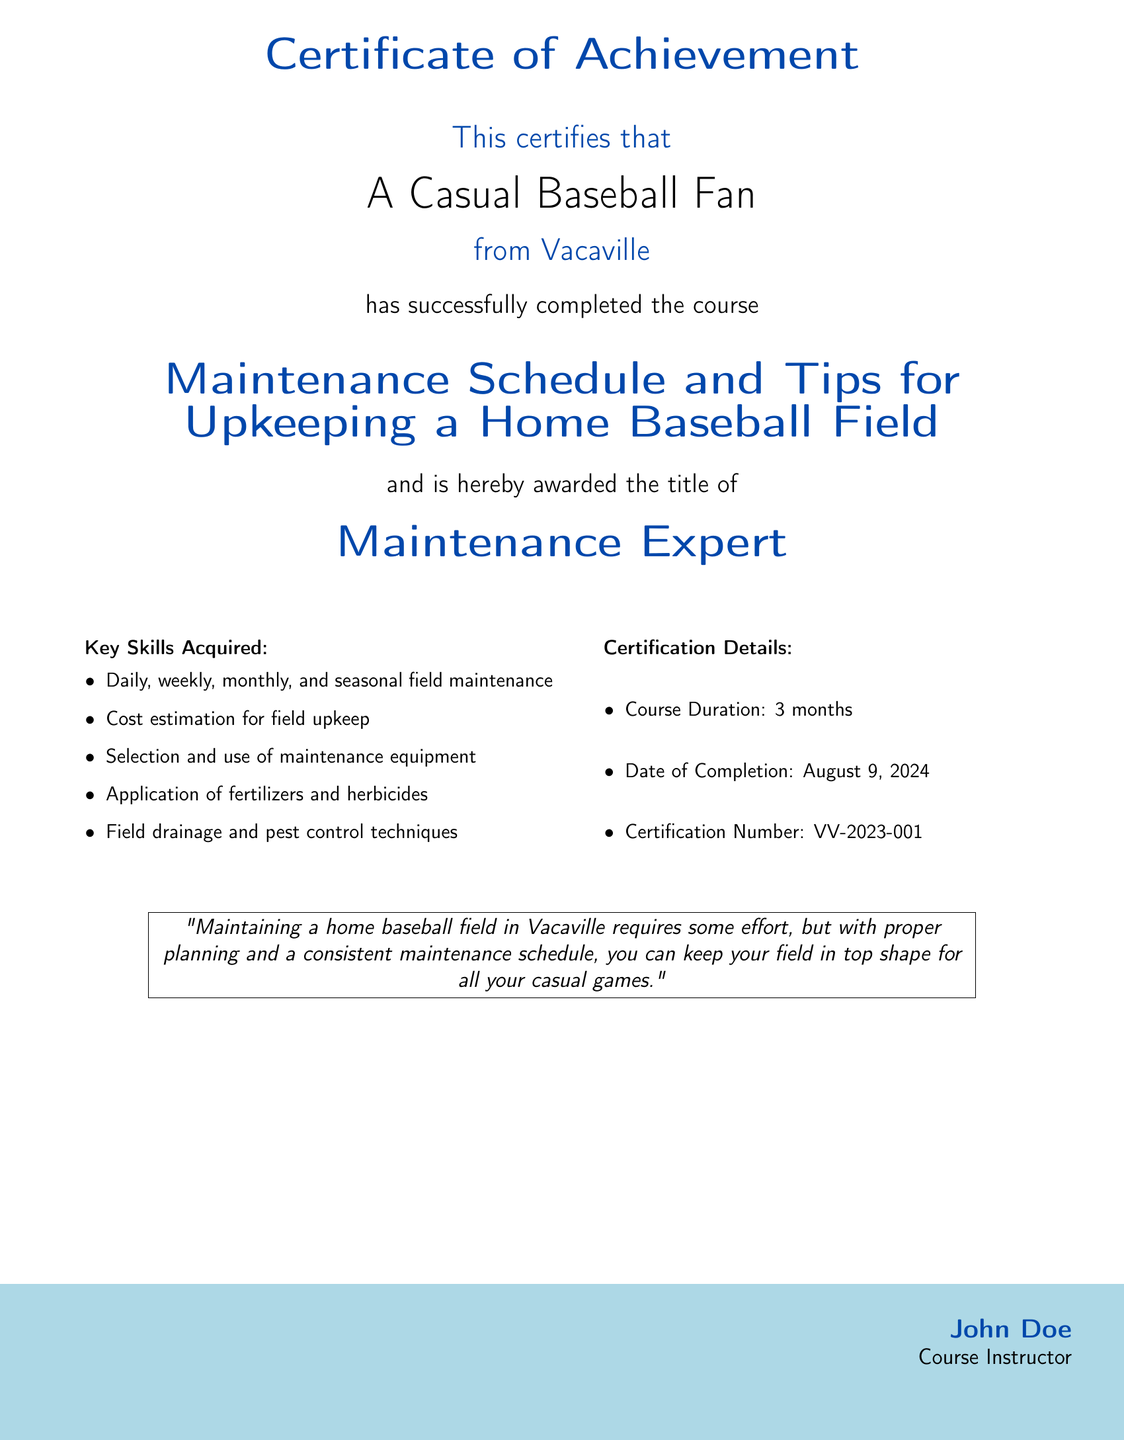what is the title of the course? The title of the course is explicitly stated in the document.
Answer: Maintenance Schedule and Tips for Upkeeping a Home Baseball Field who is the certificate awarded to? The document specifies the individual receiving the certificate with a clear name.
Answer: A Casual Baseball Fan what is the location of the recipient? The document mentions the recipient's location as part of their description.
Answer: Vacaville when was the course completed? The completion date of the course is recorded in the certification details section.
Answer: today's date how long did the course last? The duration of the course is provided in the certification details.
Answer: 3 months what is the certification number? The document includes a specific identification number for the certification.
Answer: VV-2023-001 what key skill involves applying chemicals? One of the skills listed explicitly mentions the application of substances for maintenance.
Answer: Application of fertilizers and herbicides who is the course instructor? The instructor's name is given at the bottom of the document as part of formal signing.
Answer: John Doe what color is used for the title text? The color of the title text is defined within the document's formatting elements.
Answer: basecolor 